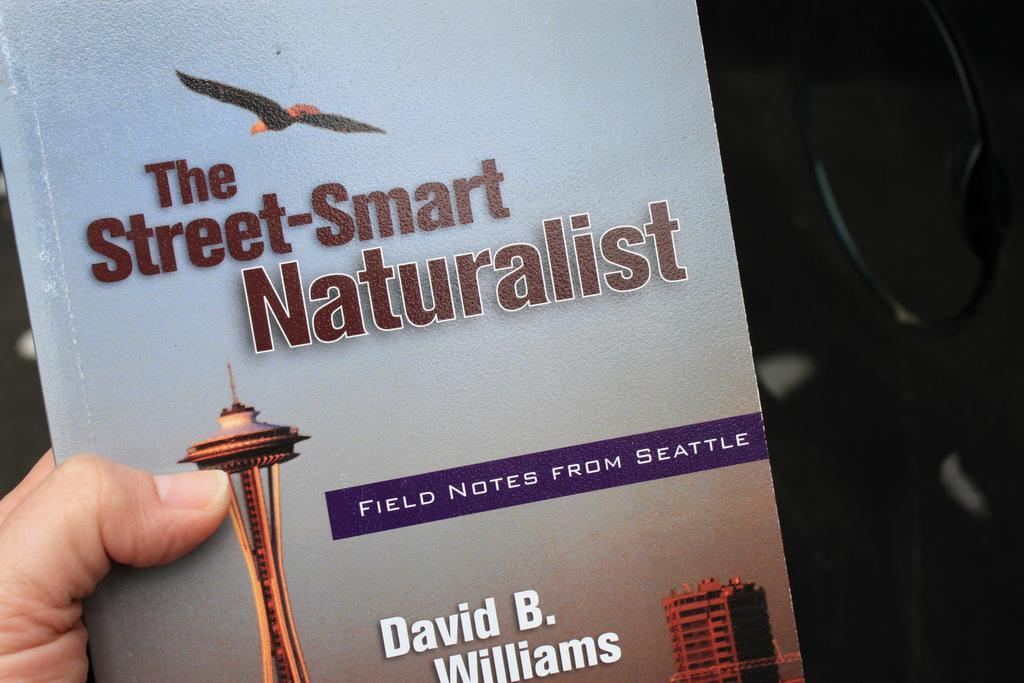<image>
Present a compact description of the photo's key features. A picture of a nature book about Seattle called "The Street-Smart Naturalist" by David B. Williams. 